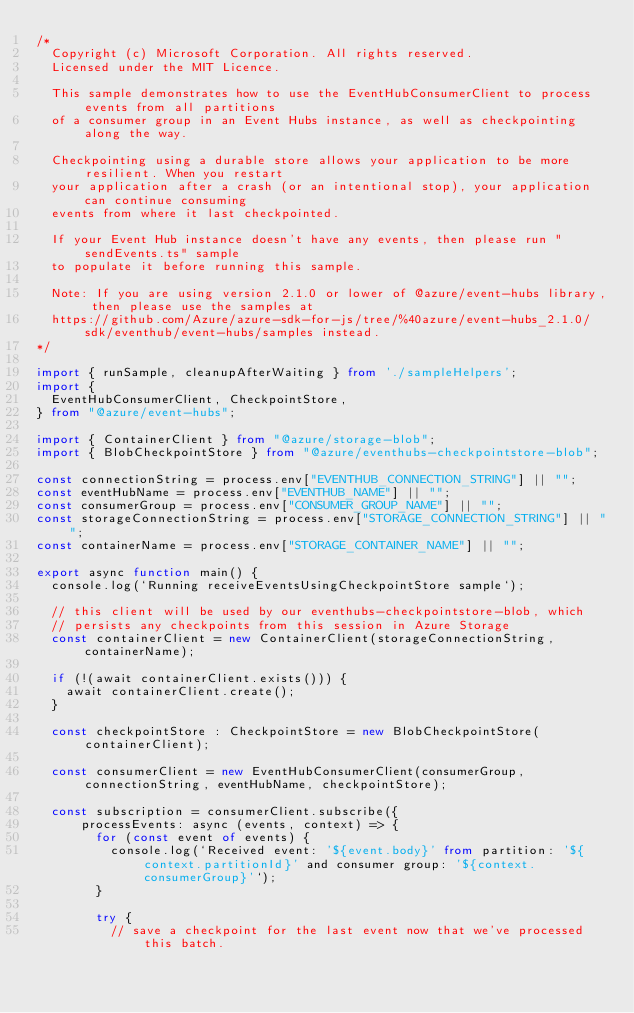<code> <loc_0><loc_0><loc_500><loc_500><_TypeScript_>/*
  Copyright (c) Microsoft Corporation. All rights reserved.
  Licensed under the MIT Licence.

  This sample demonstrates how to use the EventHubConsumerClient to process events from all partitions
  of a consumer group in an Event Hubs instance, as well as checkpointing along the way.

  Checkpointing using a durable store allows your application to be more resilient. When you restart
  your application after a crash (or an intentional stop), your application can continue consuming
  events from where it last checkpointed.
  
  If your Event Hub instance doesn't have any events, then please run "sendEvents.ts" sample
  to populate it before running this sample.

  Note: If you are using version 2.1.0 or lower of @azure/event-hubs library, then please use the samples at
  https://github.com/Azure/azure-sdk-for-js/tree/%40azure/event-hubs_2.1.0/sdk/eventhub/event-hubs/samples instead.
*/

import { runSample, cleanupAfterWaiting } from './sampleHelpers';
import {
  EventHubConsumerClient, CheckpointStore,
} from "@azure/event-hubs";

import { ContainerClient } from "@azure/storage-blob";
import { BlobCheckpointStore } from "@azure/eventhubs-checkpointstore-blob";

const connectionString = process.env["EVENTHUB_CONNECTION_STRING"] || "";
const eventHubName = process.env["EVENTHUB_NAME"] || "";
const consumerGroup = process.env["CONSUMER_GROUP_NAME"] || "";
const storageConnectionString = process.env["STORAGE_CONNECTION_STRING"] || "";
const containerName = process.env["STORAGE_CONTAINER_NAME"] || "";

export async function main() {
  console.log(`Running receiveEventsUsingCheckpointStore sample`);

  // this client will be used by our eventhubs-checkpointstore-blob, which 
  // persists any checkpoints from this session in Azure Storage
  const containerClient = new ContainerClient(storageConnectionString, containerName);

  if (!(await containerClient.exists())) {
    await containerClient.create();
  }

  const checkpointStore : CheckpointStore = new BlobCheckpointStore(containerClient);

  const consumerClient = new EventHubConsumerClient(consumerGroup, connectionString, eventHubName, checkpointStore);
   
  const subscription = consumerClient.subscribe({
      processEvents: async (events, context) => {
        for (const event of events) {
          console.log(`Received event: '${event.body}' from partition: '${context.partitionId}' and consumer group: '${context.consumerGroup}'`);
        }
    
        try {
          // save a checkpoint for the last event now that we've processed this batch.</code> 